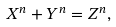<formula> <loc_0><loc_0><loc_500><loc_500>X ^ { n } + Y ^ { n } = Z ^ { n } ,</formula> 